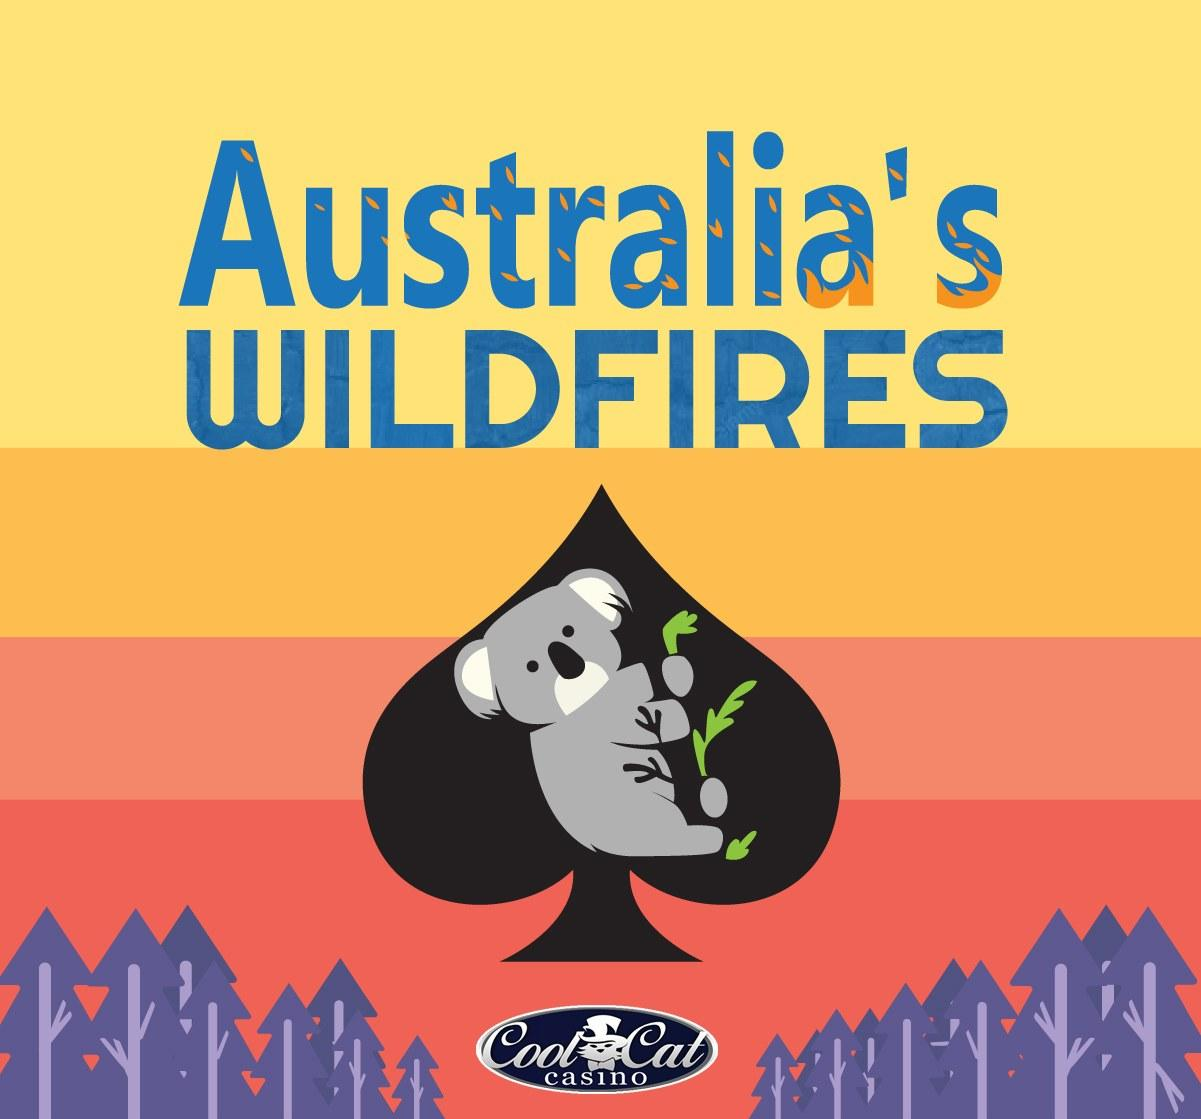Highlight a few significant elements in this photo. The animal depicted in the infographic on Australia's wildfires is a teddy bear, not a kangaroo, lion, or elephant. 